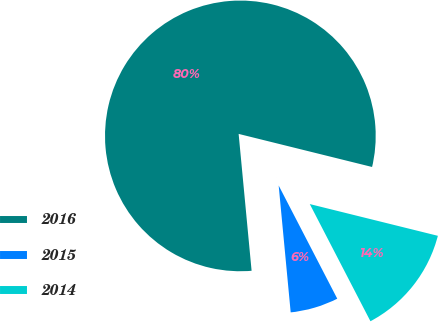<chart> <loc_0><loc_0><loc_500><loc_500><pie_chart><fcel>2016<fcel>2015<fcel>2014<nl><fcel>80.37%<fcel>6.1%<fcel>13.53%<nl></chart> 